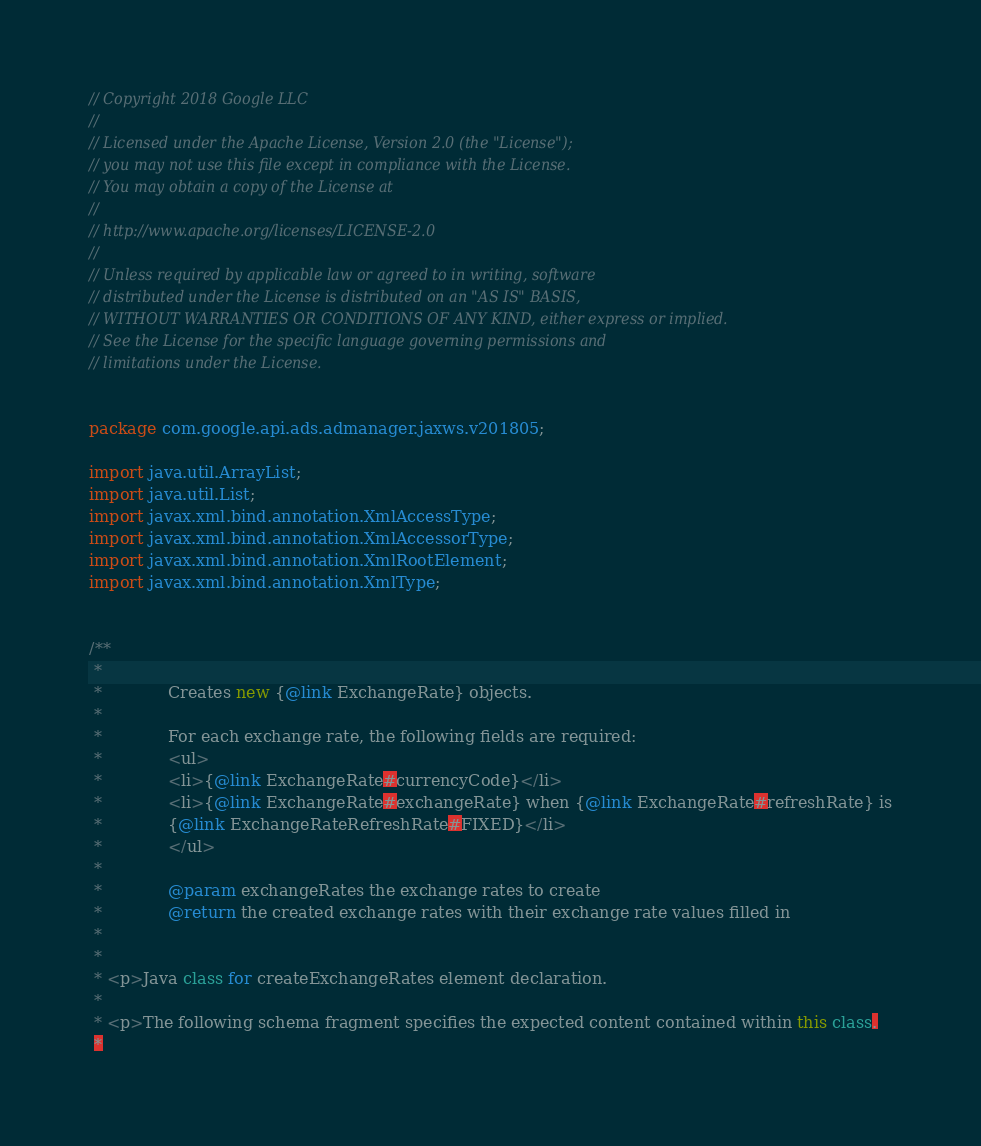Convert code to text. <code><loc_0><loc_0><loc_500><loc_500><_Java_>// Copyright 2018 Google LLC
//
// Licensed under the Apache License, Version 2.0 (the "License");
// you may not use this file except in compliance with the License.
// You may obtain a copy of the License at
//
// http://www.apache.org/licenses/LICENSE-2.0
//
// Unless required by applicable law or agreed to in writing, software
// distributed under the License is distributed on an "AS IS" BASIS,
// WITHOUT WARRANTIES OR CONDITIONS OF ANY KIND, either express or implied.
// See the License for the specific language governing permissions and
// limitations under the License.


package com.google.api.ads.admanager.jaxws.v201805;

import java.util.ArrayList;
import java.util.List;
import javax.xml.bind.annotation.XmlAccessType;
import javax.xml.bind.annotation.XmlAccessorType;
import javax.xml.bind.annotation.XmlRootElement;
import javax.xml.bind.annotation.XmlType;


/**
 * 
 *             Creates new {@link ExchangeRate} objects.
 *             
 *             For each exchange rate, the following fields are required:
 *             <ul>
 *             <li>{@link ExchangeRate#currencyCode}</li>
 *             <li>{@link ExchangeRate#exchangeRate} when {@link ExchangeRate#refreshRate} is
 *             {@link ExchangeRateRefreshRate#FIXED}</li>
 *             </ul>
 *             
 *             @param exchangeRates the exchange rates to create
 *             @return the created exchange rates with their exchange rate values filled in
 *           
 * 
 * <p>Java class for createExchangeRates element declaration.
 * 
 * <p>The following schema fragment specifies the expected content contained within this class.
 * </code> 